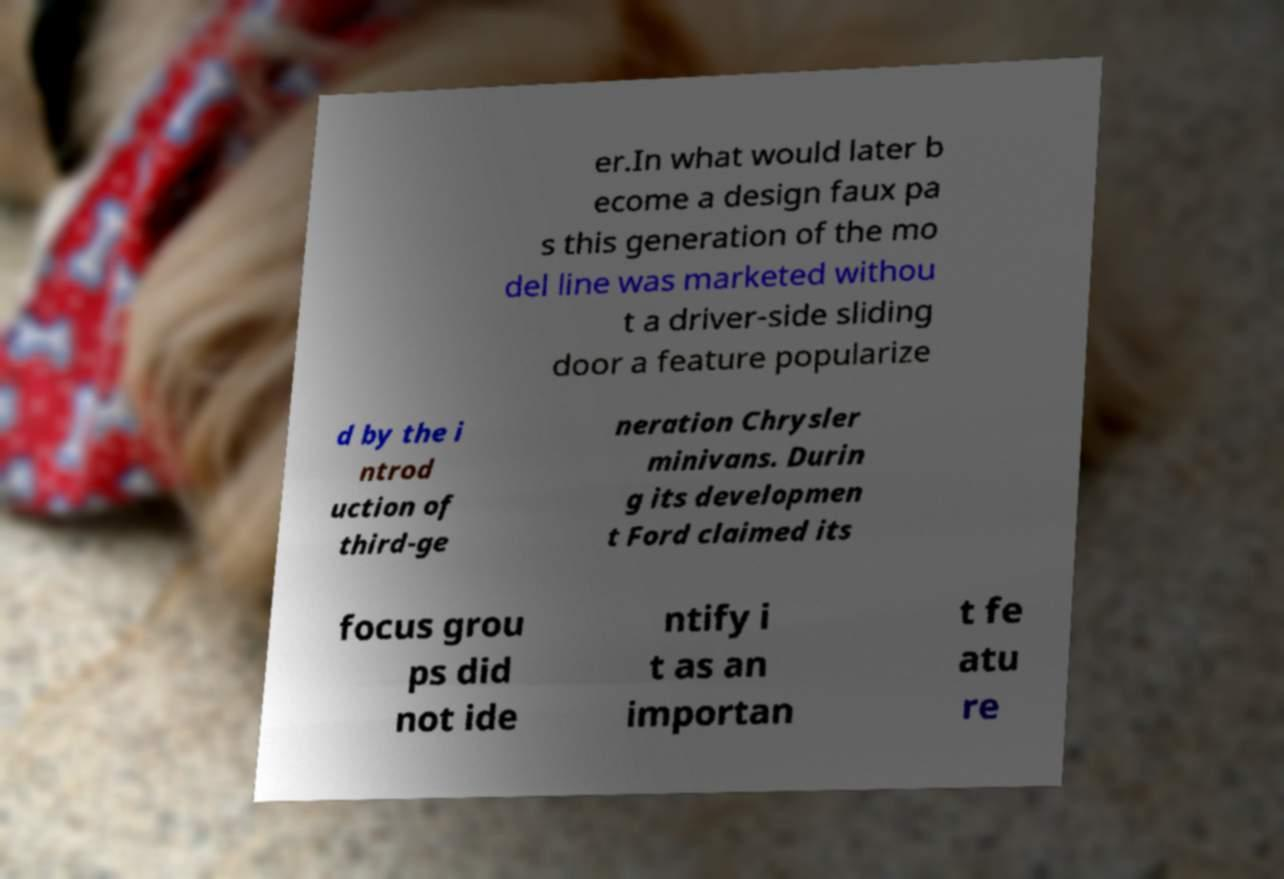Please identify and transcribe the text found in this image. er.In what would later b ecome a design faux pa s this generation of the mo del line was marketed withou t a driver-side sliding door a feature popularize d by the i ntrod uction of third-ge neration Chrysler minivans. Durin g its developmen t Ford claimed its focus grou ps did not ide ntify i t as an importan t fe atu re 